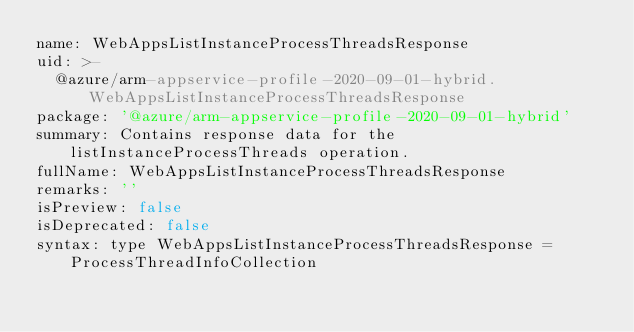Convert code to text. <code><loc_0><loc_0><loc_500><loc_500><_YAML_>name: WebAppsListInstanceProcessThreadsResponse
uid: >-
  @azure/arm-appservice-profile-2020-09-01-hybrid.WebAppsListInstanceProcessThreadsResponse
package: '@azure/arm-appservice-profile-2020-09-01-hybrid'
summary: Contains response data for the listInstanceProcessThreads operation.
fullName: WebAppsListInstanceProcessThreadsResponse
remarks: ''
isPreview: false
isDeprecated: false
syntax: type WebAppsListInstanceProcessThreadsResponse = ProcessThreadInfoCollection
</code> 